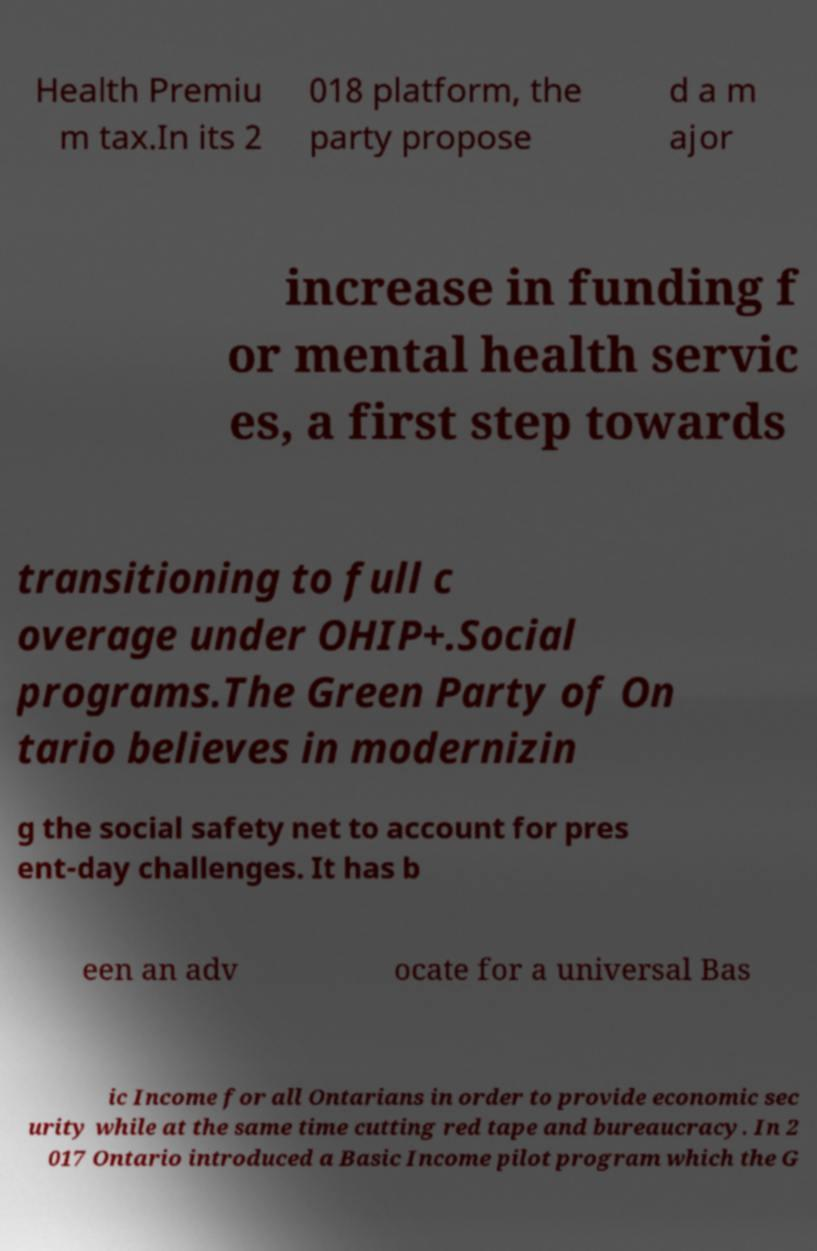I need the written content from this picture converted into text. Can you do that? Health Premiu m tax.In its 2 018 platform, the party propose d a m ajor increase in funding f or mental health servic es, a first step towards transitioning to full c overage under OHIP+.Social programs.The Green Party of On tario believes in modernizin g the social safety net to account for pres ent-day challenges. It has b een an adv ocate for a universal Bas ic Income for all Ontarians in order to provide economic sec urity while at the same time cutting red tape and bureaucracy. In 2 017 Ontario introduced a Basic Income pilot program which the G 